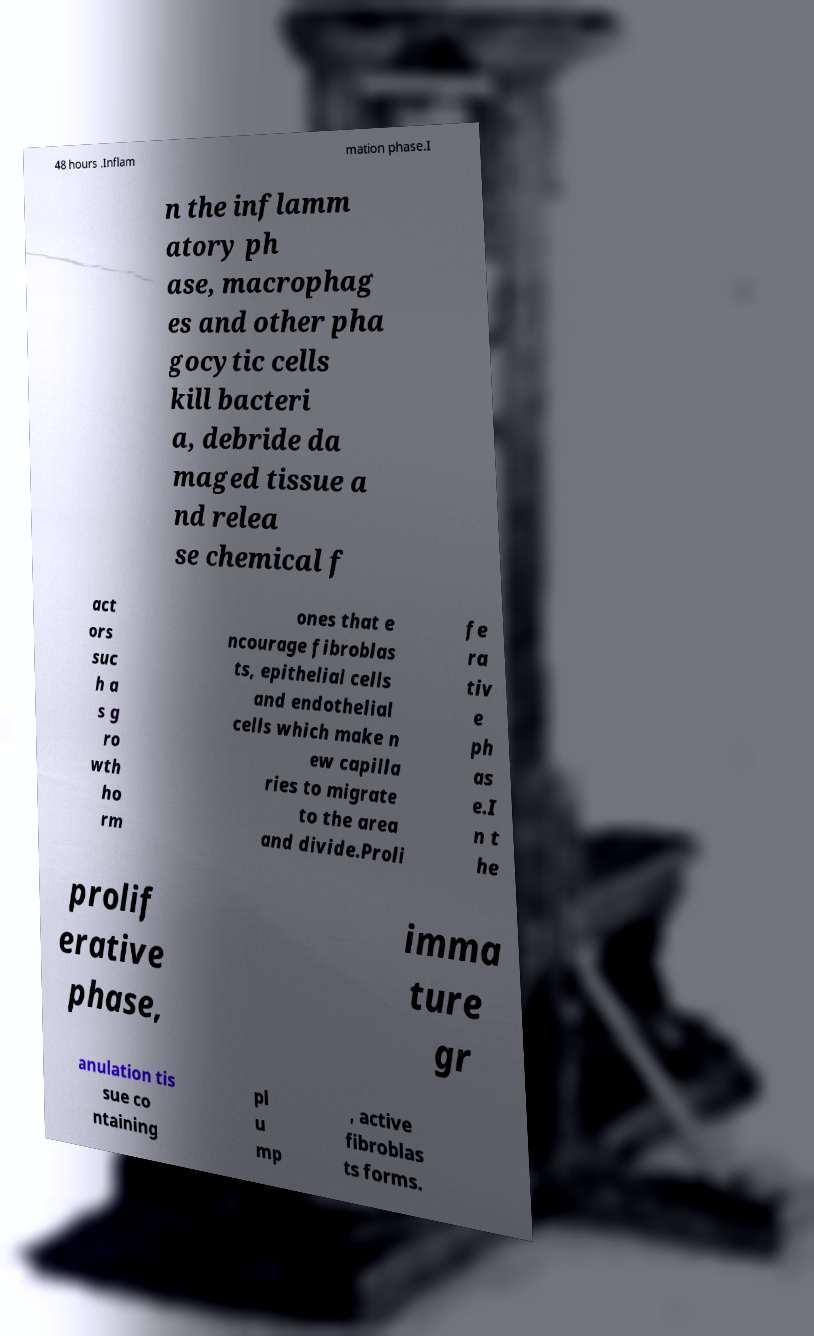Please read and relay the text visible in this image. What does it say? 48 hours .Inflam mation phase.I n the inflamm atory ph ase, macrophag es and other pha gocytic cells kill bacteri a, debride da maged tissue a nd relea se chemical f act ors suc h a s g ro wth ho rm ones that e ncourage fibroblas ts, epithelial cells and endothelial cells which make n ew capilla ries to migrate to the area and divide.Proli fe ra tiv e ph as e.I n t he prolif erative phase, imma ture gr anulation tis sue co ntaining pl u mp , active fibroblas ts forms. 